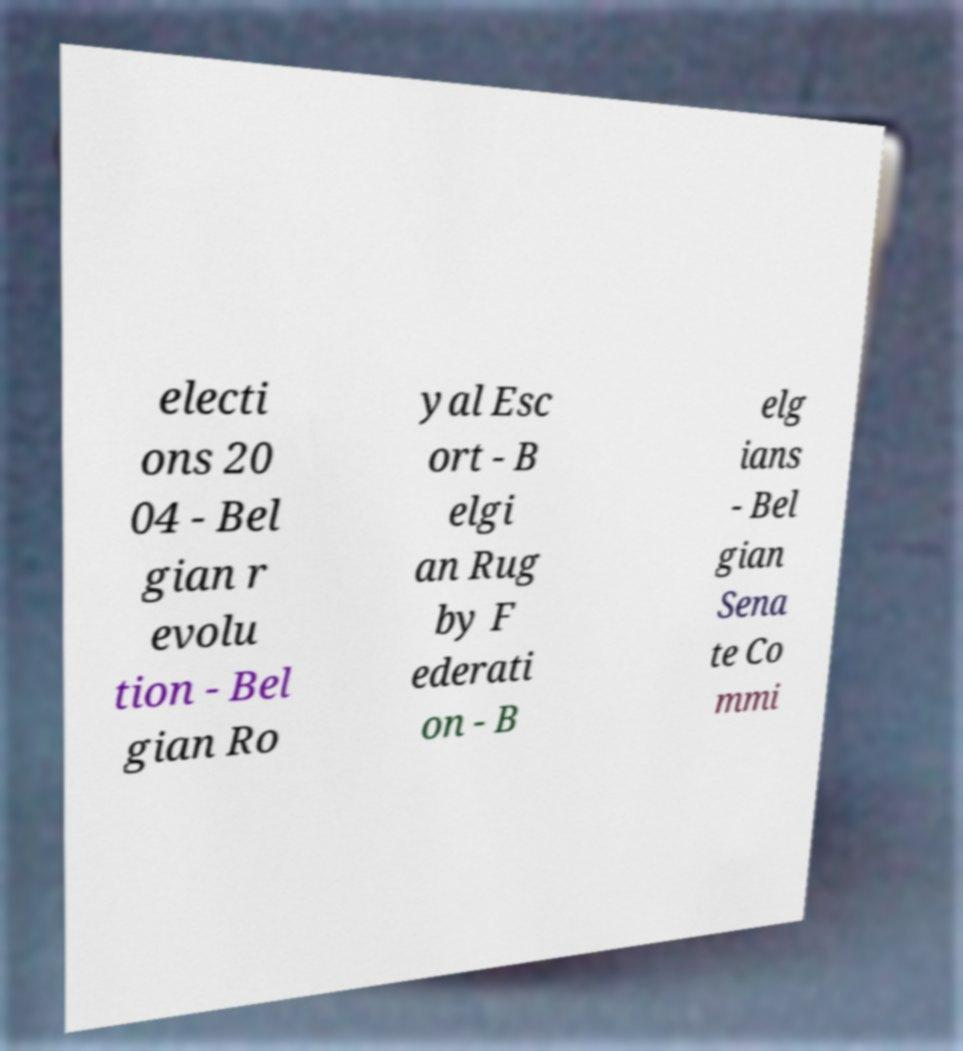For documentation purposes, I need the text within this image transcribed. Could you provide that? electi ons 20 04 - Bel gian r evolu tion - Bel gian Ro yal Esc ort - B elgi an Rug by F ederati on - B elg ians - Bel gian Sena te Co mmi 